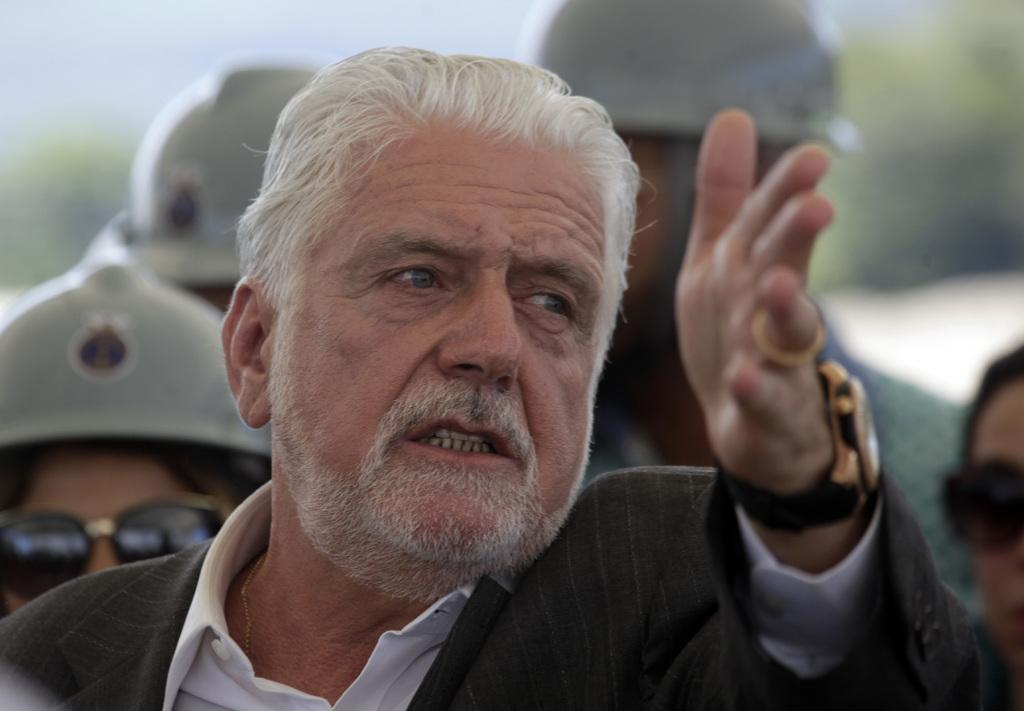Who or what can be seen in the image? There are people in the image. What are some of the people wearing? Some people are wearing helmets and sunglasses. Can you describe the background of the image? The background of the image is blurry. Is there a cobweb visible in the image? There is no cobweb present in the image. How many rings can be seen on the fingers of the people in the image? There is no mention of rings in the image, so it cannot be determined how many rings are visible. 